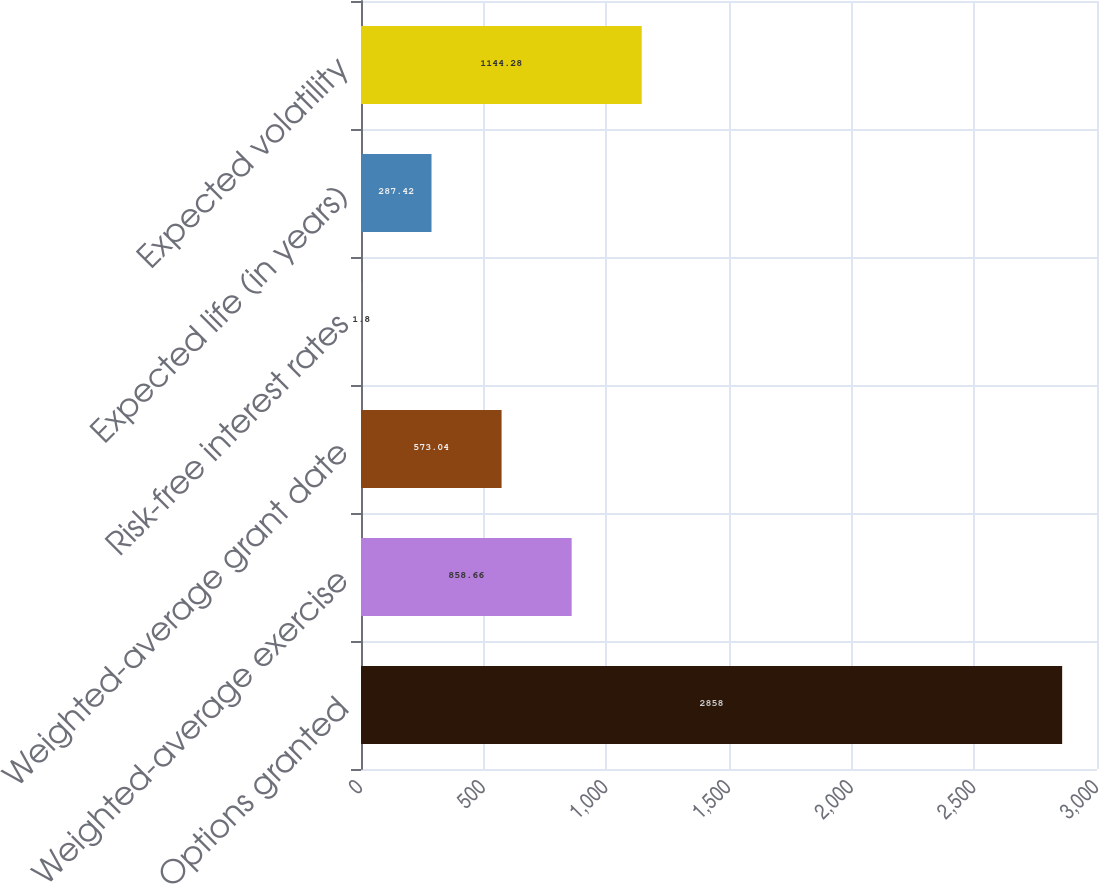<chart> <loc_0><loc_0><loc_500><loc_500><bar_chart><fcel>Options granted<fcel>Weighted-average exercise<fcel>Weighted-average grant date<fcel>Risk-free interest rates<fcel>Expected life (in years)<fcel>Expected volatility<nl><fcel>2858<fcel>858.66<fcel>573.04<fcel>1.8<fcel>287.42<fcel>1144.28<nl></chart> 